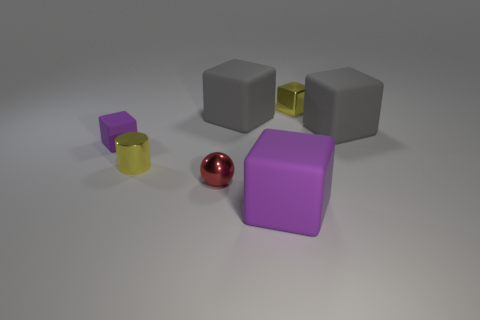Subtract all red cylinders. How many gray cubes are left? 2 Subtract all small yellow cubes. How many cubes are left? 4 Subtract all purple blocks. How many blocks are left? 3 Add 2 cubes. How many objects exist? 9 Subtract all cyan cubes. Subtract all blue cylinders. How many cubes are left? 5 Subtract all cylinders. How many objects are left? 6 Subtract all tiny yellow shiny cylinders. Subtract all red shiny objects. How many objects are left? 5 Add 1 red things. How many red things are left? 2 Add 1 purple blocks. How many purple blocks exist? 3 Subtract 0 green cylinders. How many objects are left? 7 